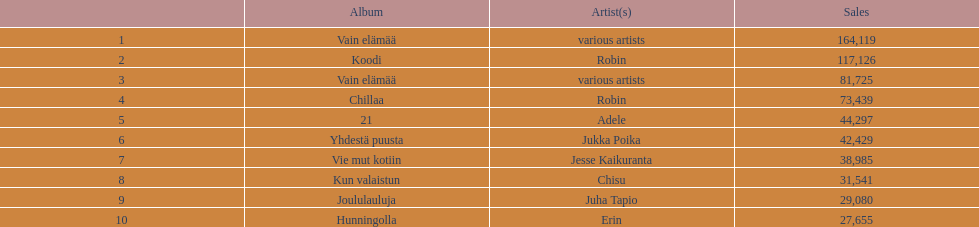What is an album that has the same artist who made chillaa? Koodi. 